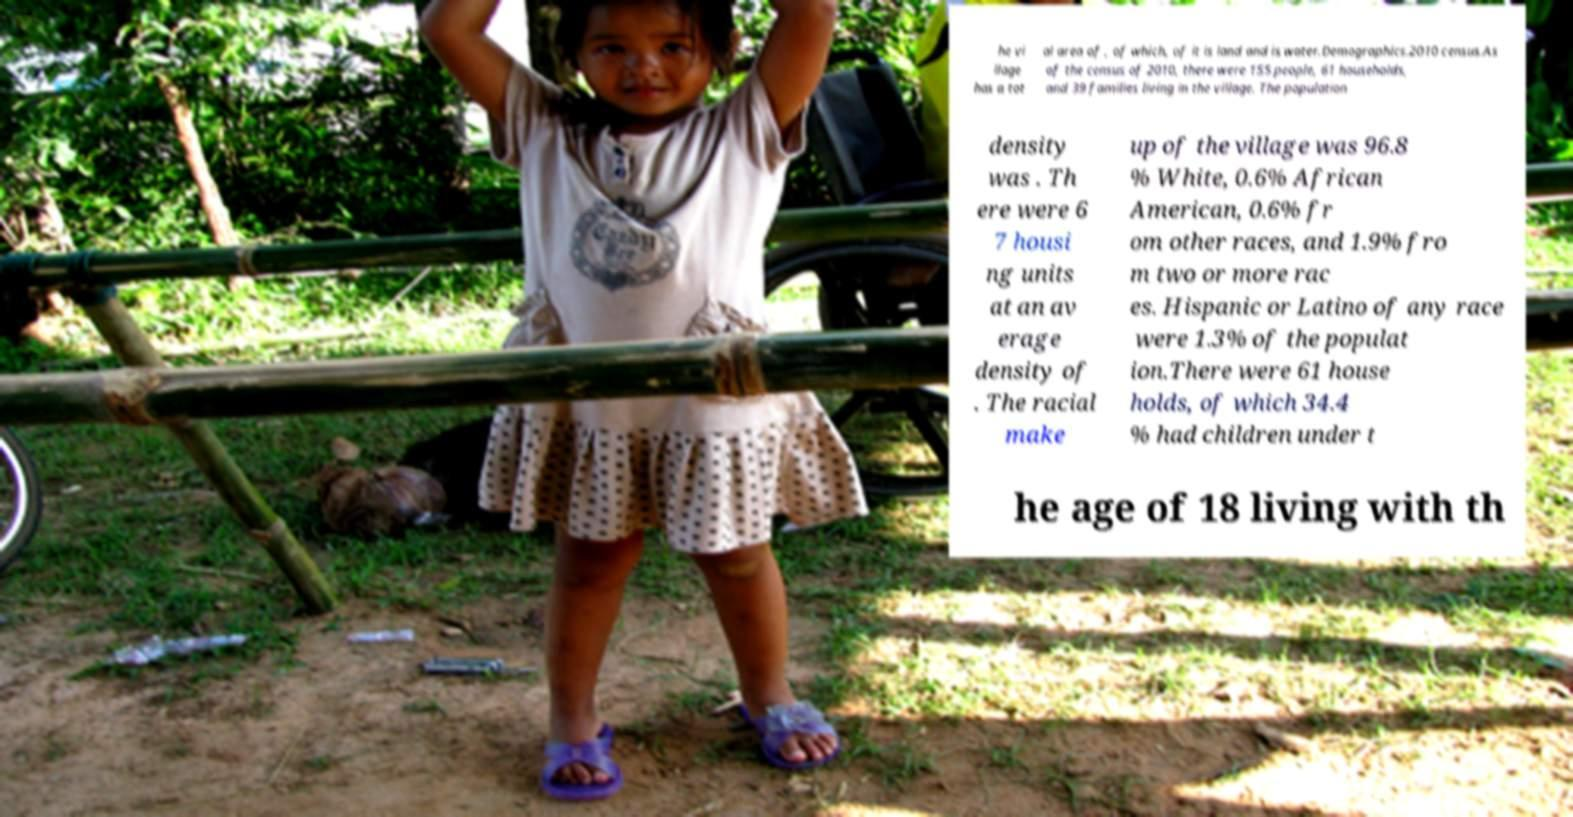Can you accurately transcribe the text from the provided image for me? he vi llage has a tot al area of , of which, of it is land and is water.Demographics.2010 census.As of the census of 2010, there were 155 people, 61 households, and 39 families living in the village. The population density was . Th ere were 6 7 housi ng units at an av erage density of . The racial make up of the village was 96.8 % White, 0.6% African American, 0.6% fr om other races, and 1.9% fro m two or more rac es. Hispanic or Latino of any race were 1.3% of the populat ion.There were 61 house holds, of which 34.4 % had children under t he age of 18 living with th 